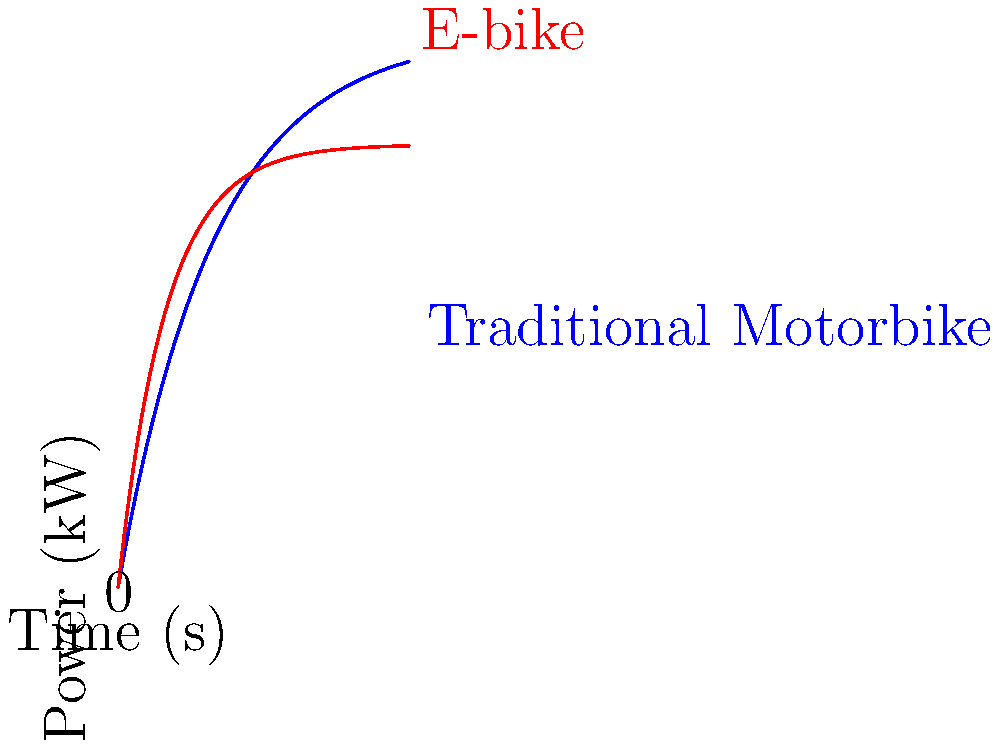The graph shows the power output curves for a traditional motorbike and an e-bike over time. The traditional motorbike has a mass of 180 kg, while the e-bike has a mass of 25 kg. Calculate the difference in power-to-weight ratio (in W/kg) between the traditional motorbike and the e-bike at t = 20 seconds. Which vehicle has the higher power-to-weight ratio at this time point? To solve this problem, we'll follow these steps:

1. Determine the power output for each vehicle at t = 20 seconds:
   - Traditional motorbike: $P_m = 50(1-e^{-20/10}) \approx 43.26$ kW
   - E-bike: $P_e = 40(1-e^{-20/5}) \approx 39.35$ kW

2. Convert power from kW to W:
   - Traditional motorbike: $43.26 \times 1000 = 43260$ W
   - E-bike: $39.35 \times 1000 = 39350$ W

3. Calculate power-to-weight ratio for each vehicle:
   - Traditional motorbike: $\frac{43260 \text{ W}}{180 \text{ kg}} \approx 240.33$ W/kg
   - E-bike: $\frac{39350 \text{ W}}{25 \text{ kg}} = 1574$ W/kg

4. Calculate the difference in power-to-weight ratio:
   $1574 - 240.33 = 1333.67$ W/kg

The e-bike has the higher power-to-weight ratio at t = 20 seconds.
Answer: 1333.67 W/kg, e-bike 